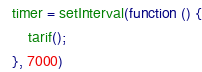<code> <loc_0><loc_0><loc_500><loc_500><_JavaScript_>timer = setInterval(function () {
	tarif();
}, 7000)
</code> 